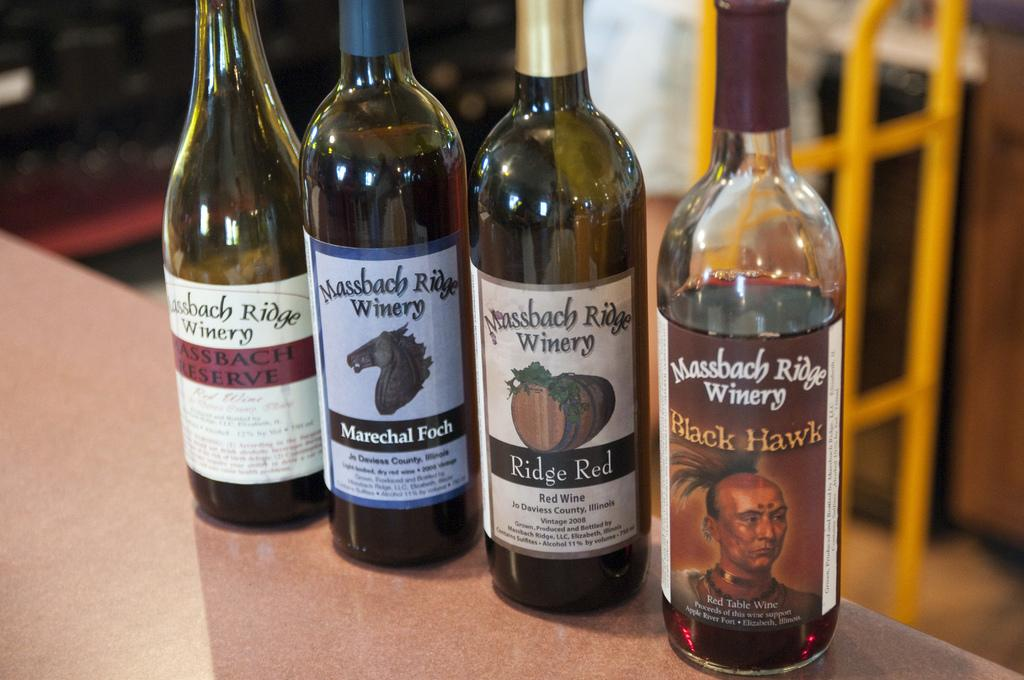Provide a one-sentence caption for the provided image. four bottles of wine from a place called Massbach ridge. 